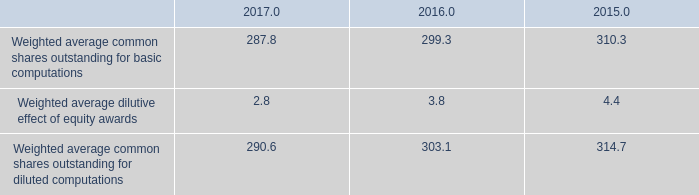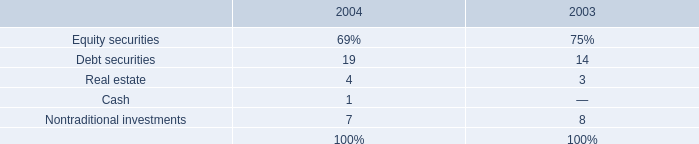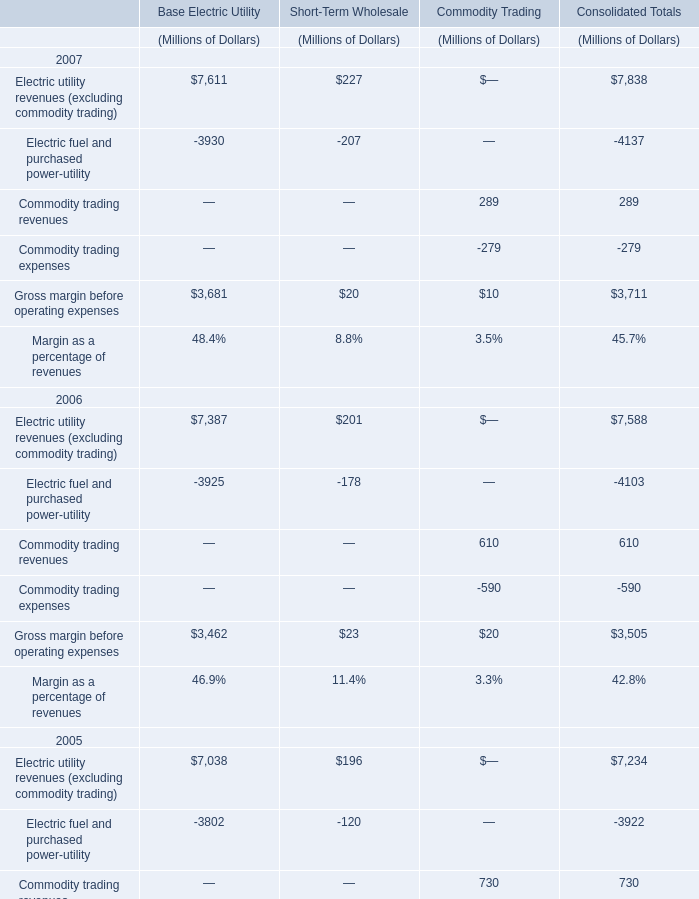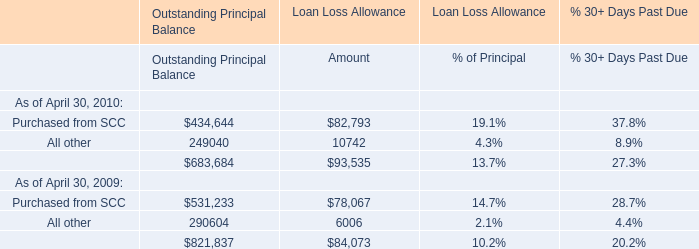As As the chart 2 shows,which year is the value of the Commodity trading revenues for Commodity Trading the lowest? 
Answer: 2007. 